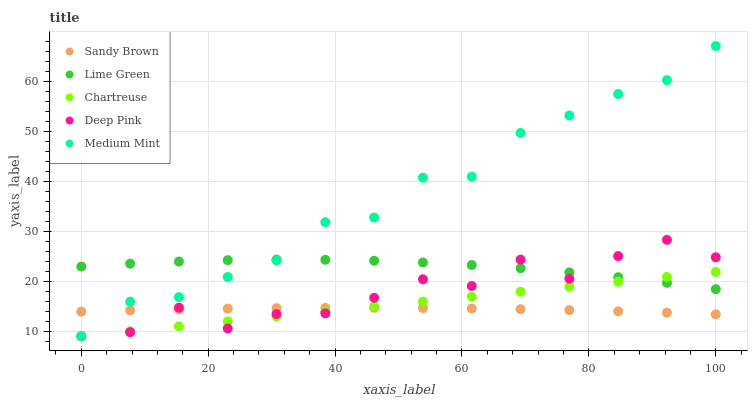Does Sandy Brown have the minimum area under the curve?
Answer yes or no. Yes. Does Medium Mint have the maximum area under the curve?
Answer yes or no. Yes. Does Lime Green have the minimum area under the curve?
Answer yes or no. No. Does Lime Green have the maximum area under the curve?
Answer yes or no. No. Is Chartreuse the smoothest?
Answer yes or no. Yes. Is Deep Pink the roughest?
Answer yes or no. Yes. Is Lime Green the smoothest?
Answer yes or no. No. Is Lime Green the roughest?
Answer yes or no. No. Does Medium Mint have the lowest value?
Answer yes or no. Yes. Does Lime Green have the lowest value?
Answer yes or no. No. Does Medium Mint have the highest value?
Answer yes or no. Yes. Does Lime Green have the highest value?
Answer yes or no. No. Is Sandy Brown less than Lime Green?
Answer yes or no. Yes. Is Lime Green greater than Sandy Brown?
Answer yes or no. Yes. Does Chartreuse intersect Deep Pink?
Answer yes or no. Yes. Is Chartreuse less than Deep Pink?
Answer yes or no. No. Is Chartreuse greater than Deep Pink?
Answer yes or no. No. Does Sandy Brown intersect Lime Green?
Answer yes or no. No. 